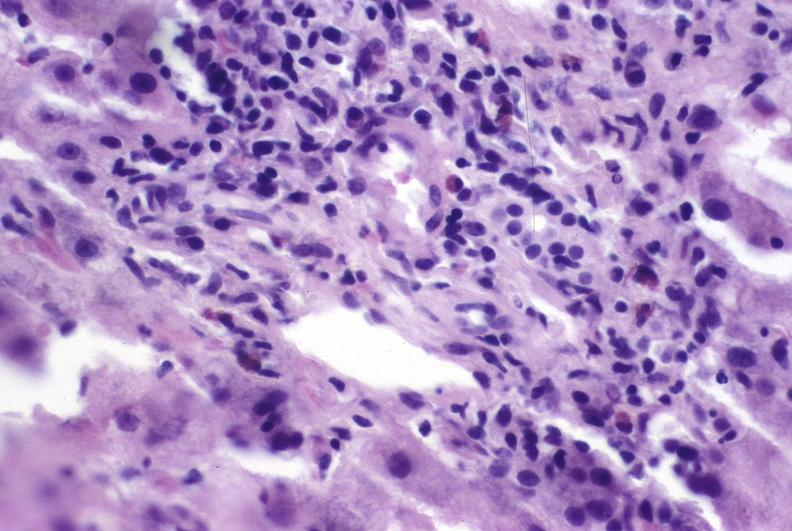does this image show autoimmune hepatitis?
Answer the question using a single word or phrase. Yes 